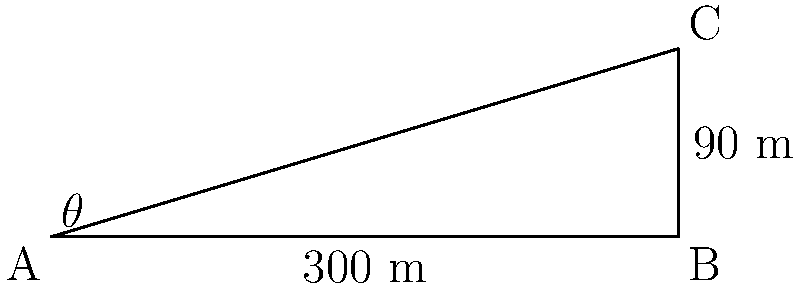At a scenic overlook, you're standing at point A, looking up at the top of a cliff (point C). The base of the cliff (point B) is 300 meters away from you horizontally, and the cliff is 90 meters tall. What is the viewing angle $\theta$ (in degrees) from your position to the top of the cliff? To solve this problem, we'll use trigonometry:

1. We have a right triangle ABC, where:
   - AB is the horizontal distance (300 m)
   - BC is the height of the cliff (90 m)
   - AC is the line of sight
   - $\theta$ is the angle we need to find

2. We can use the tangent function to find $\theta$:

   $\tan(\theta) = \frac{\text{opposite}}{\text{adjacent}} = \frac{BC}{AB} = \frac{90}{300} = 0.3$

3. To find $\theta$, we need to use the inverse tangent (arctan or $\tan^{-1}$):

   $\theta = \tan^{-1}(0.3)$

4. Using a calculator or trigonometric tables:

   $\theta \approx 16.70^\circ$

5. Round to two decimal places:

   $\theta \approx 16.70^\circ$

This angle represents the upward tilt of your line of sight when viewing the top of the cliff from the scenic overlook.
Answer: $16.70^\circ$ 